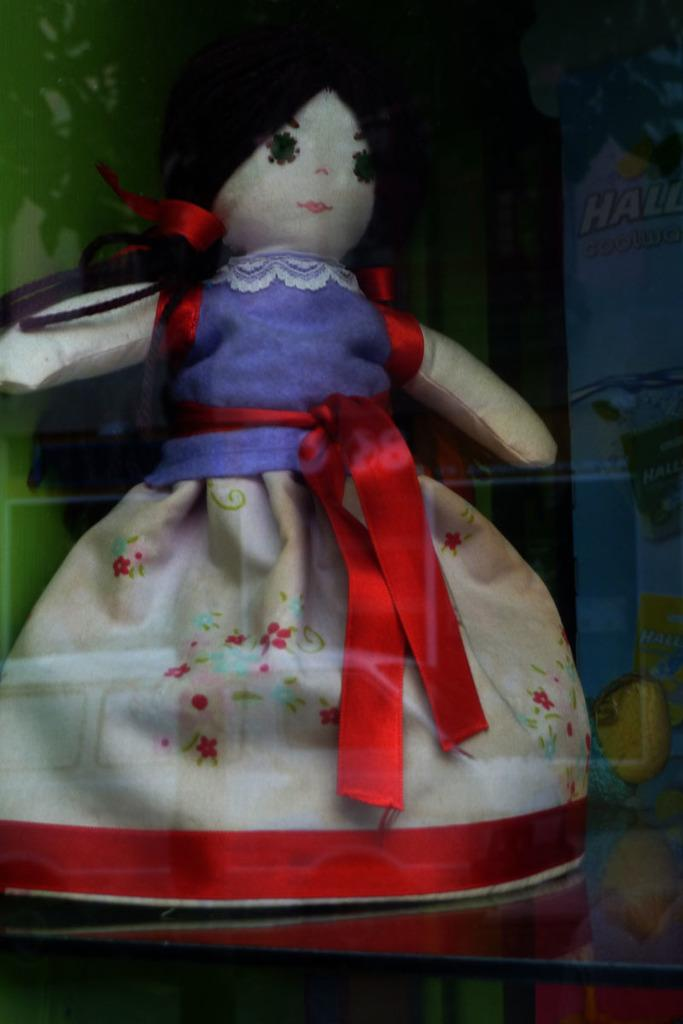What is the main subject in the image? There is a doll in the image. What is the doll placed on? The doll is on a glass surface. Is there a stranger in the image conducting business in a tub? No, there is no stranger, business, or tub present in the image. The image only features a doll on a glass surface. 